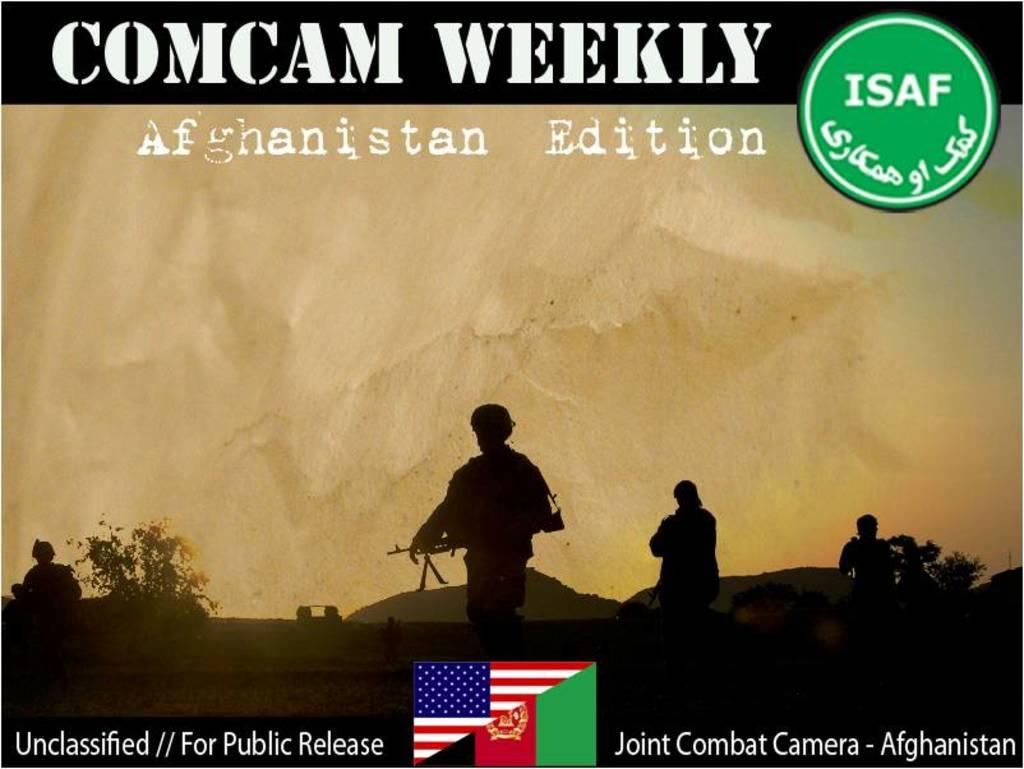Provide a one-sentence caption for the provided image. An advertisement for Comcam Weekly Afganistan Edition featuring silhouettes of soldiers. 